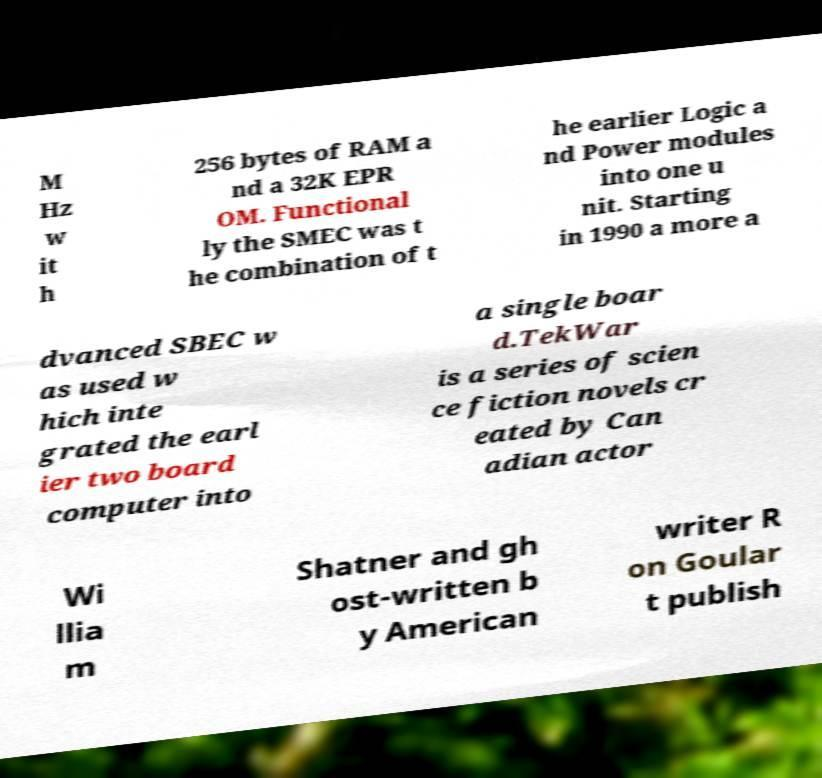Please identify and transcribe the text found in this image. M Hz w it h 256 bytes of RAM a nd a 32K EPR OM. Functional ly the SMEC was t he combination of t he earlier Logic a nd Power modules into one u nit. Starting in 1990 a more a dvanced SBEC w as used w hich inte grated the earl ier two board computer into a single boar d.TekWar is a series of scien ce fiction novels cr eated by Can adian actor Wi llia m Shatner and gh ost-written b y American writer R on Goular t publish 